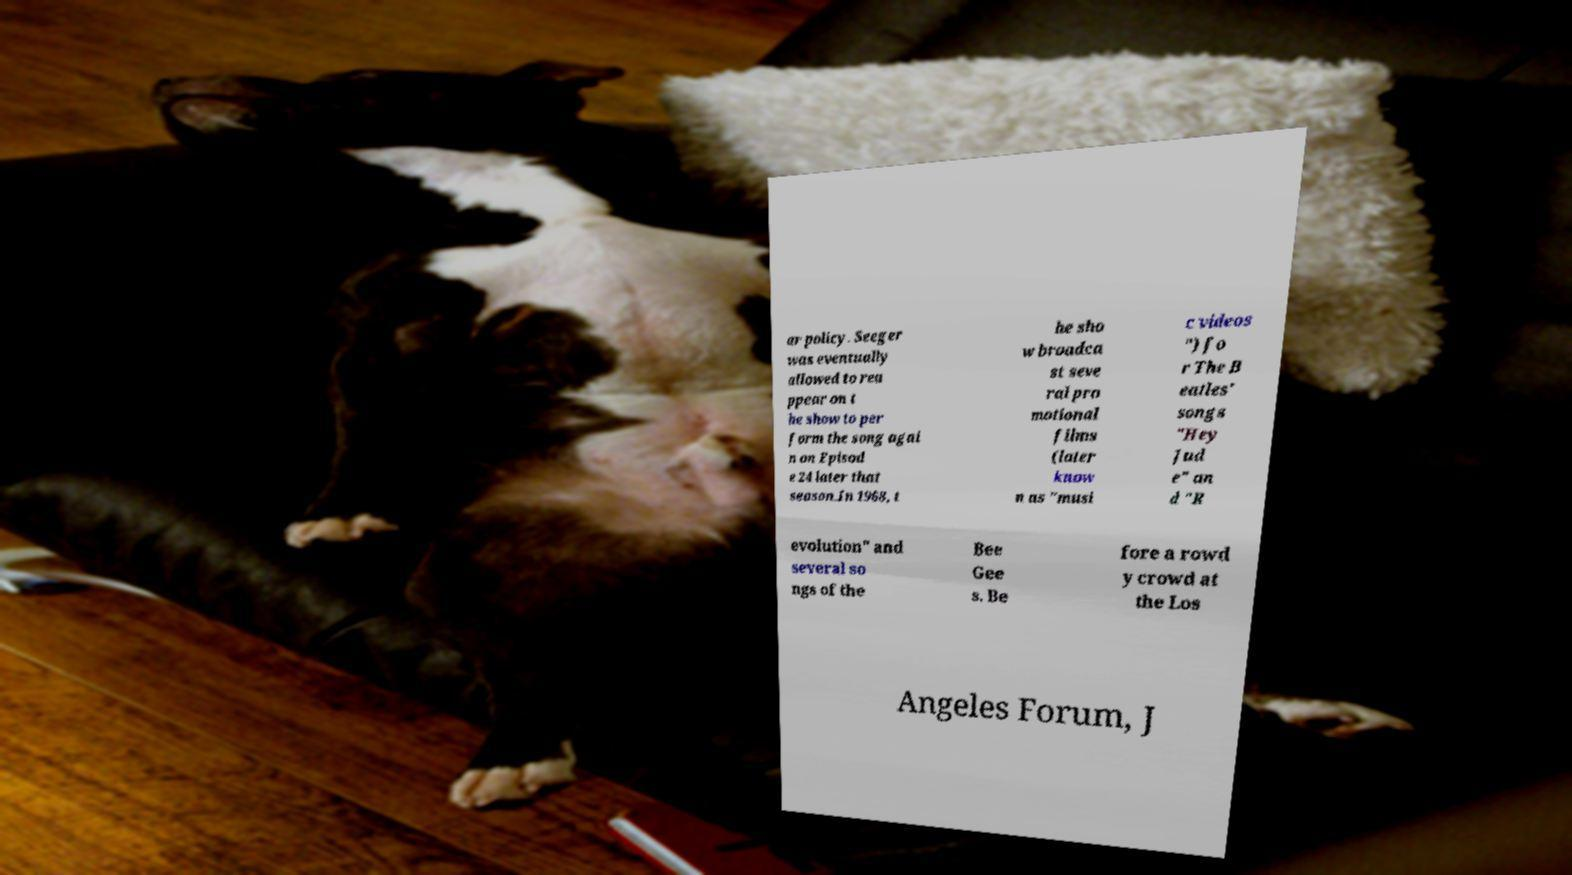Please identify and transcribe the text found in this image. ar policy. Seeger was eventually allowed to rea ppear on t he show to per form the song agai n on Episod e 24 later that season.In 1968, t he sho w broadca st seve ral pro motional films (later know n as "musi c videos ") fo r The B eatles' songs "Hey Jud e" an d "R evolution" and several so ngs of the Bee Gee s. Be fore a rowd y crowd at the Los Angeles Forum, J 